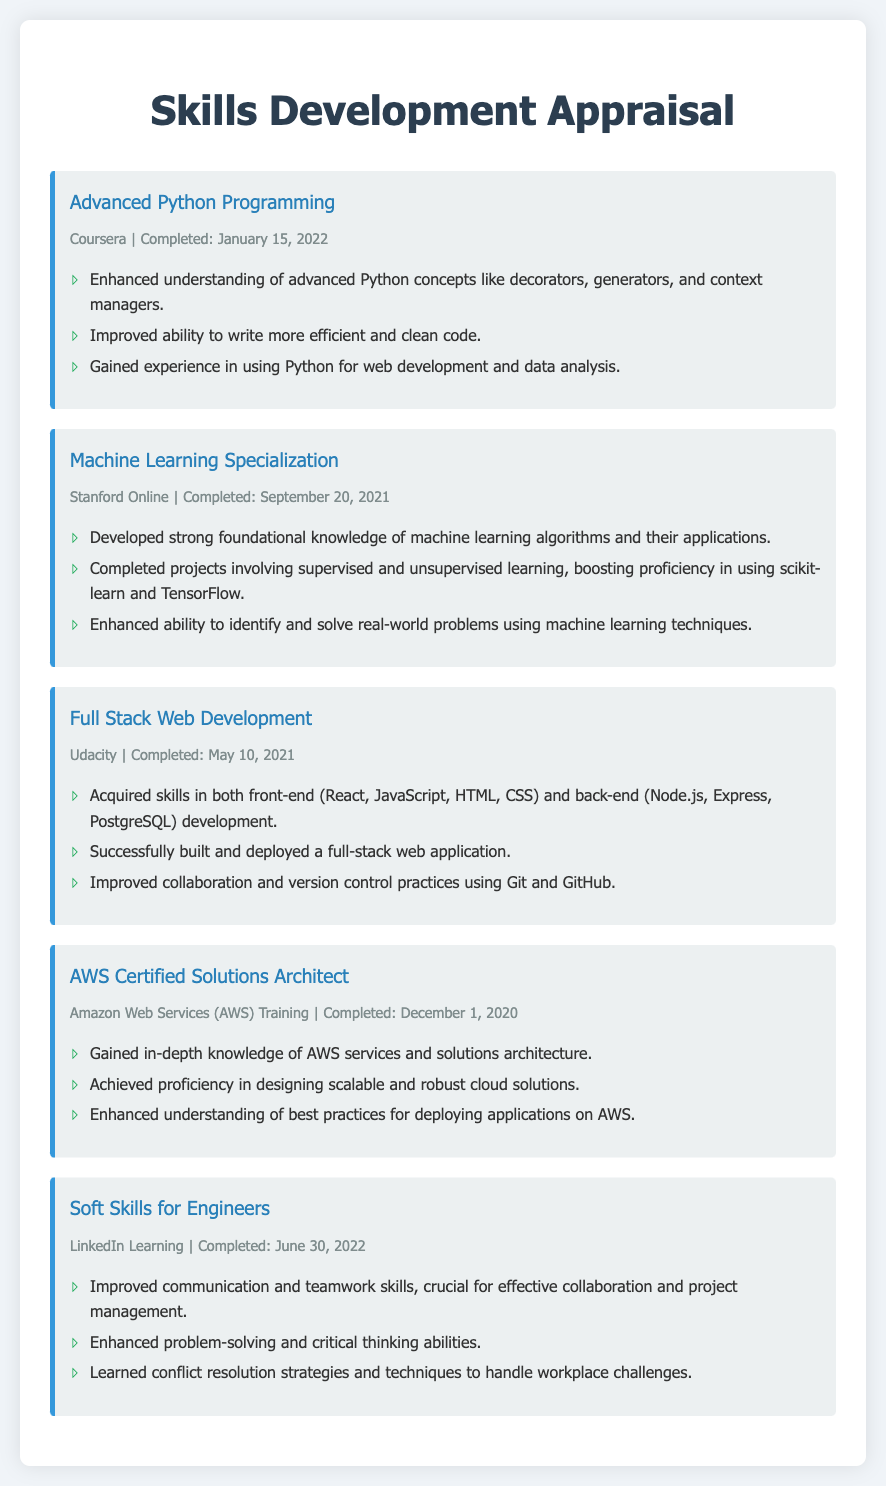What is the title of the first skill developed? The first skill listed in the document is "Advanced Python Programming."
Answer: Advanced Python Programming When was the Machine Learning Specialization completed? The document states it was completed on September 20, 2021.
Answer: September 20, 2021 Which platform offered the Full Stack Web Development course? The course was offered on Udacity, as per the information in the document.
Answer: Udacity What is one outcome of completing the AWS Certified Solutions Architect training? The document mentions gaining in-depth knowledge of AWS services and solutions architecture as an outcome.
Answer: In-depth knowledge of AWS services What skills were acquired in the Soft Skills for Engineers course? The document lists improved communication and teamwork skills as a direct outcome of the course.
Answer: Improved communication and teamwork skills What was the completion date of the Advanced Python Programming course? The completion date mentioned in the document is January 15, 2022.
Answer: January 15, 2022 Which programming framework was mentioned for front-end development? React is the programming framework noted for front-end development in the document.
Answer: React Which skill is associated with cloud solutions? The skill associated with cloud solutions is "AWS Certified Solutions Architect."
Answer: AWS Certified Solutions Architect How many skills were detailed in the appraisal form? The document describes a total of five skills in the appraisal form.
Answer: Five skills 